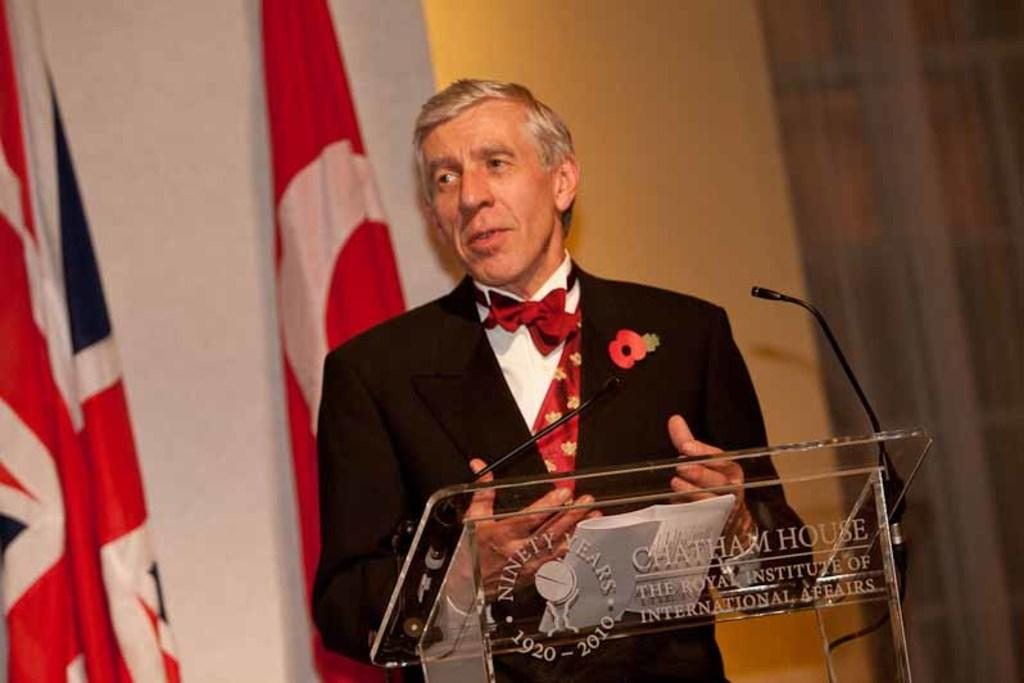Who is the main subject in the image? There is a man in the middle of the image. What is the man wearing? The man is wearing a suit, shirt, trouser, and tie. What is in front of the man? There is a podium in front of the man. What is on the podium? There is a microphone on the podium. What can be seen in the background of the image? There are flags and a wall in the background of the image. What is the man's profit margin for the year in the image? There is no information about the man's profit margin in the image. What type of spade is the man holding in the image? There is no spade present in the image. 